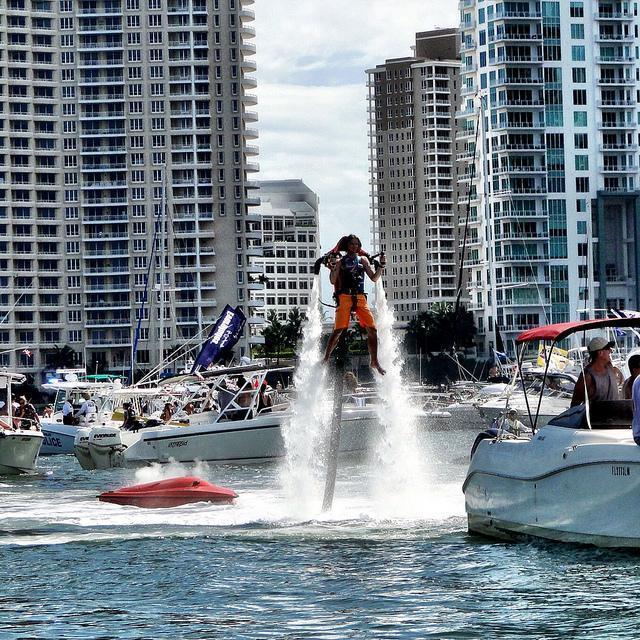What power allows the man to to airborne?
Pick the correct solution from the four options below to address the question.
Options: Water pump, mental, solar, magic. Water pump. 